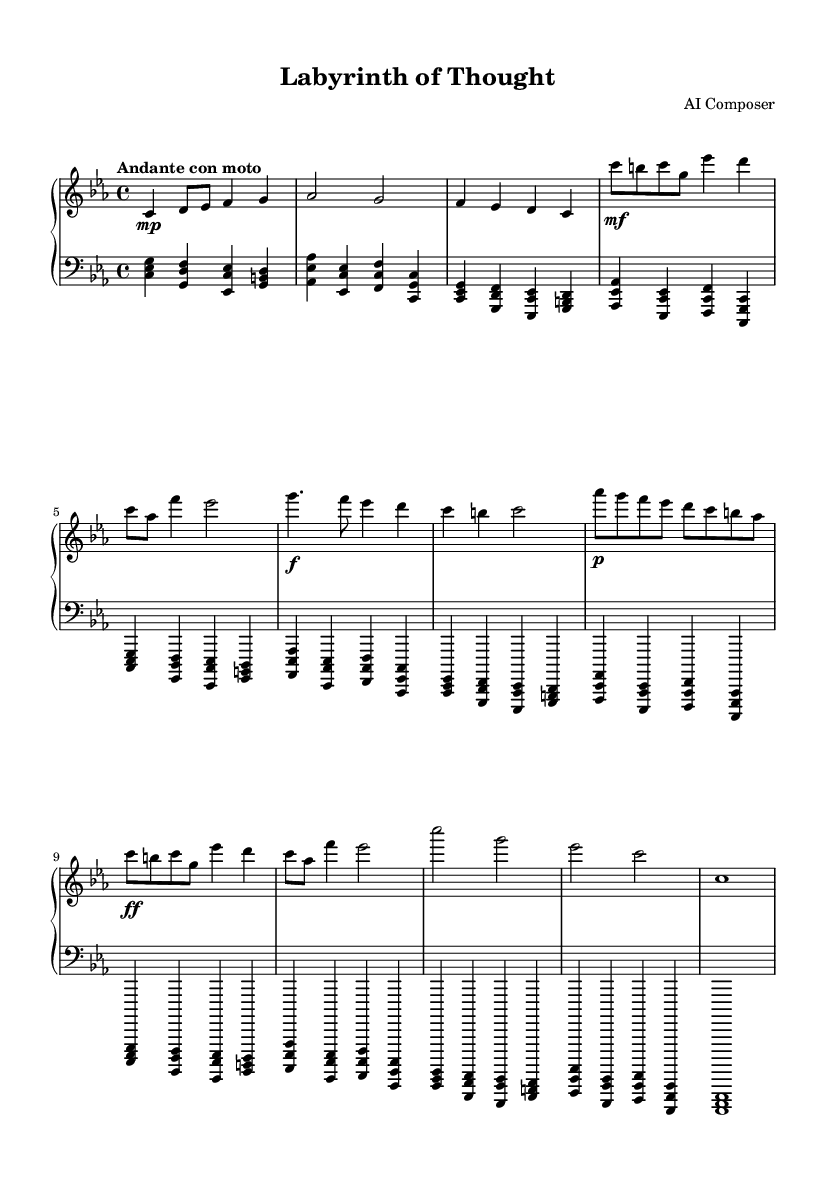What is the key signature of this music? The key signature is C minor, which has three flats (B flat, E flat, A flat). This can be determined by looking at the key signature indicated at the beginning of the piece.
Answer: C minor What is the time signature of this music? The time signature is 4/4, as indicated by the notation at the beginning of the piece. This means there are four beats in each measure, and a quarter note receives one beat.
Answer: 4/4 What is the tempo marking of this music? The tempo marking is "Andante con moto," which indicates a moderately slow tempo with a sense of movement. This is specified at the beginning of the music.
Answer: Andante con moto What is the total number of measures in the piece? By counting the measures in both the upper and lower staves, there are a total of 20 measures in the piece. This requires a careful count of the measure bars shown throughout the staff.
Answer: 20 Identify one dynamic marking in the upper staff. The upper staff has a dynamic marking of "mf" (mezzo-forte) at measure 5. This denotes a medium loudness. By closely inspecting the dynamics written in the music, it can be identified.
Answer: mf In which section does Theme A first appear? Theme A first appears after the introduction, specifically in the measures 5 to 6 (second section). Recognizing the different sections of the composition helps pinpoint when Theme A is introduced.
Answer: Measure 5 How many different themes are present in this piece? There are two distinct themes present in the piece: Theme A and Theme B. This can be discerned from the labels and the different melodic ideas presented in the respective sections of the music.
Answer: 2 